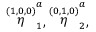Convert formula to latex. <formula><loc_0><loc_0><loc_500><loc_500>\stackrel { ( 1 , 0 , 0 ) } { \eta } _ { 1 } ^ { a } , \stackrel { ( 0 , 1 , 0 ) } { \eta } _ { 2 } ^ { a } ,</formula> 